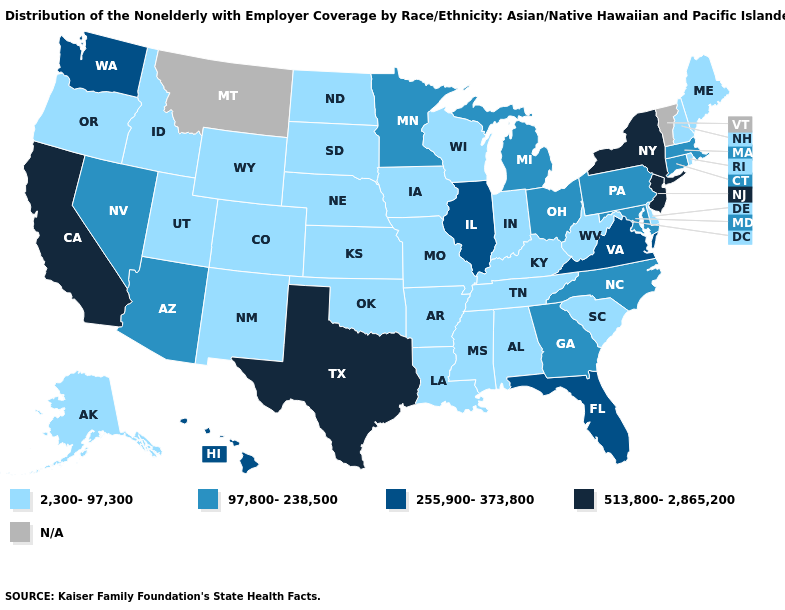Which states have the highest value in the USA?
Write a very short answer. California, New Jersey, New York, Texas. Which states have the lowest value in the USA?
Short answer required. Alabama, Alaska, Arkansas, Colorado, Delaware, Idaho, Indiana, Iowa, Kansas, Kentucky, Louisiana, Maine, Mississippi, Missouri, Nebraska, New Hampshire, New Mexico, North Dakota, Oklahoma, Oregon, Rhode Island, South Carolina, South Dakota, Tennessee, Utah, West Virginia, Wisconsin, Wyoming. Among the states that border New Mexico , does Texas have the highest value?
Concise answer only. Yes. What is the lowest value in states that border Rhode Island?
Keep it brief. 97,800-238,500. Does the first symbol in the legend represent the smallest category?
Concise answer only. Yes. Which states have the highest value in the USA?
Answer briefly. California, New Jersey, New York, Texas. Name the states that have a value in the range 97,800-238,500?
Keep it brief. Arizona, Connecticut, Georgia, Maryland, Massachusetts, Michigan, Minnesota, Nevada, North Carolina, Ohio, Pennsylvania. Does North Carolina have the lowest value in the South?
Keep it brief. No. What is the lowest value in the USA?
Write a very short answer. 2,300-97,300. What is the highest value in the USA?
Be succinct. 513,800-2,865,200. Does Tennessee have the lowest value in the South?
Answer briefly. Yes. Does Texas have the highest value in the South?
Be succinct. Yes. Does the map have missing data?
Keep it brief. Yes. 